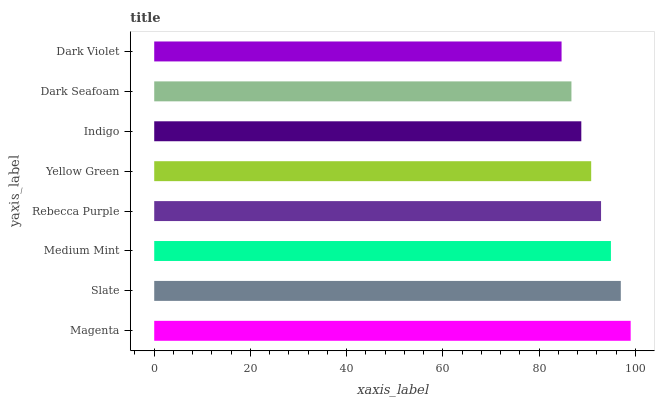Is Dark Violet the minimum?
Answer yes or no. Yes. Is Magenta the maximum?
Answer yes or no. Yes. Is Slate the minimum?
Answer yes or no. No. Is Slate the maximum?
Answer yes or no. No. Is Magenta greater than Slate?
Answer yes or no. Yes. Is Slate less than Magenta?
Answer yes or no. Yes. Is Slate greater than Magenta?
Answer yes or no. No. Is Magenta less than Slate?
Answer yes or no. No. Is Rebecca Purple the high median?
Answer yes or no. Yes. Is Yellow Green the low median?
Answer yes or no. Yes. Is Indigo the high median?
Answer yes or no. No. Is Indigo the low median?
Answer yes or no. No. 